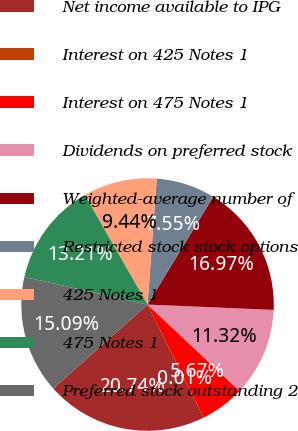Convert chart. <chart><loc_0><loc_0><loc_500><loc_500><pie_chart><fcel>Net income available to IPG<fcel>Interest on 425 Notes 1<fcel>Interest on 475 Notes 1<fcel>Dividends on preferred stock<fcel>Weighted-average number of<fcel>Restricted stock stock options<fcel>425 Notes 1<fcel>475 Notes 1<fcel>Preferred stock outstanding 2<nl><fcel>20.74%<fcel>0.01%<fcel>5.67%<fcel>11.32%<fcel>16.97%<fcel>7.55%<fcel>9.44%<fcel>13.21%<fcel>15.09%<nl></chart> 